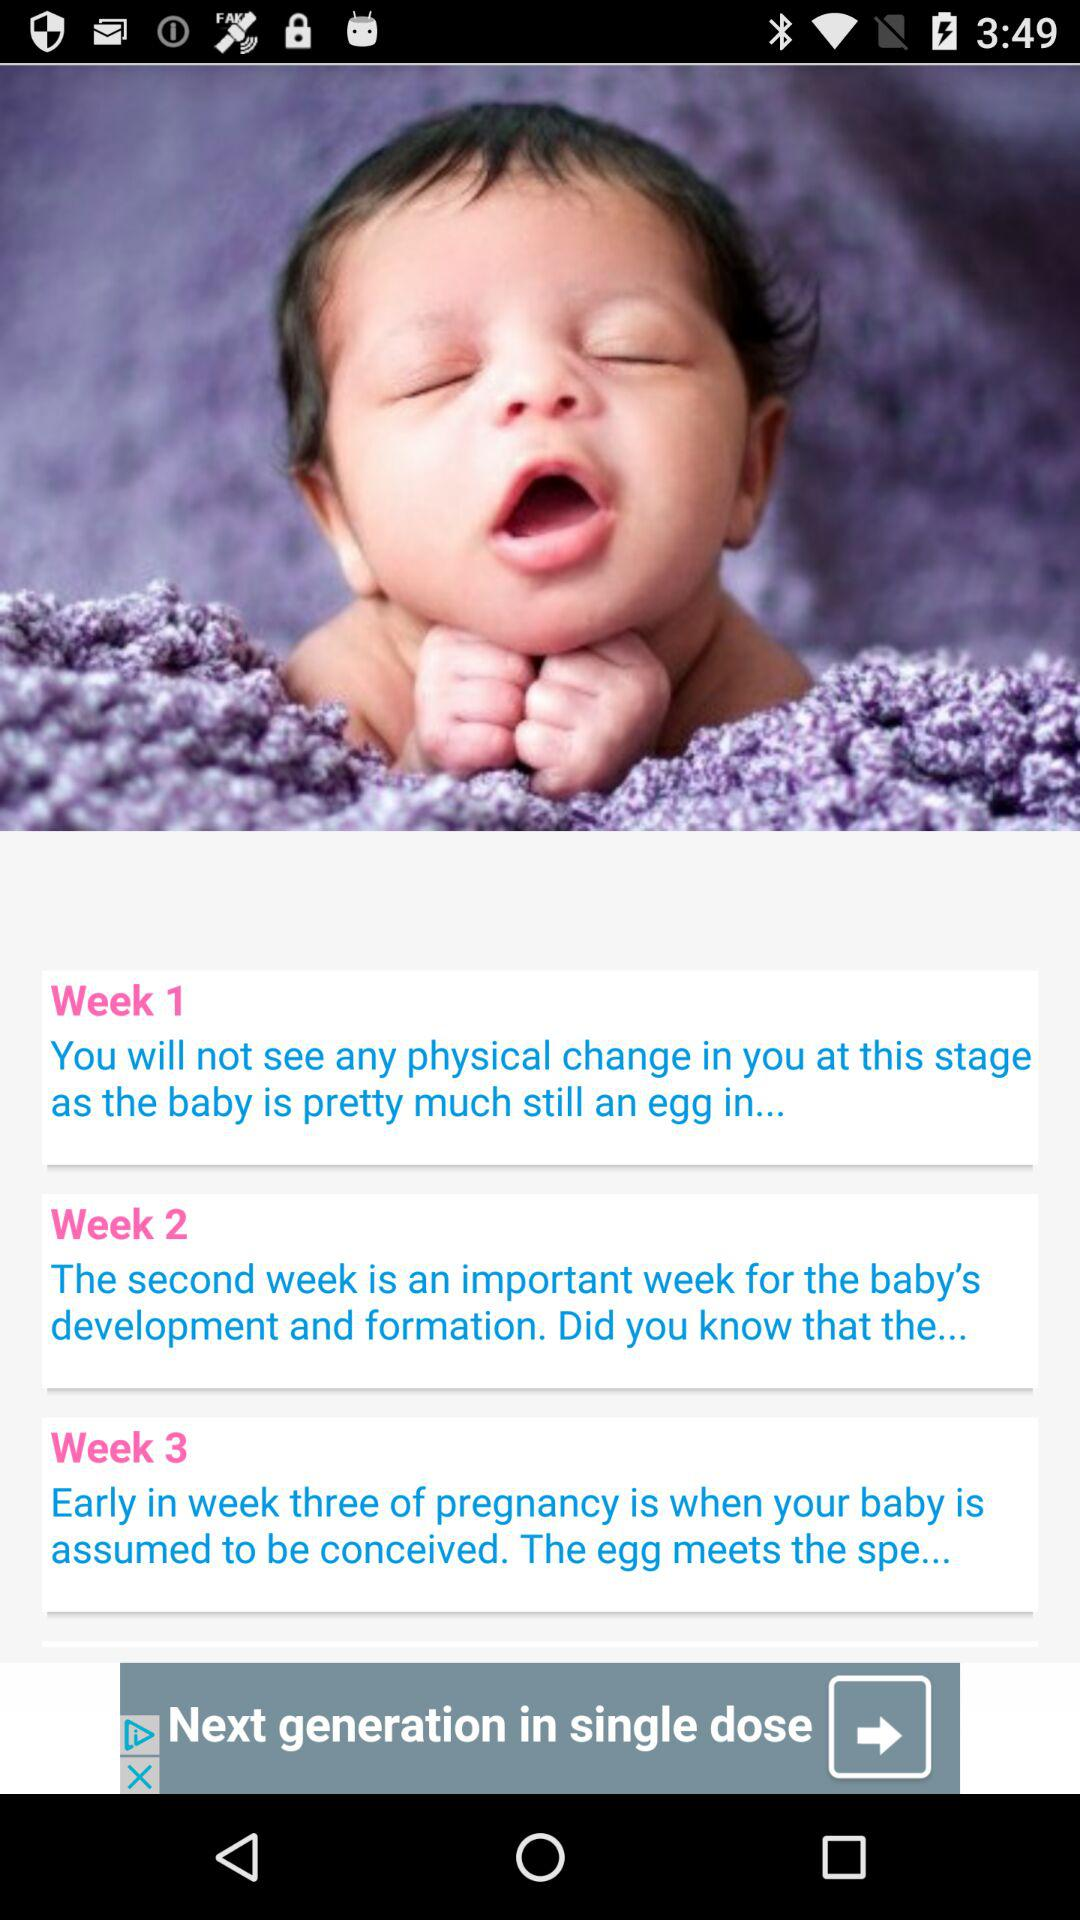How many total weeks does a baby take to be conceived? The baby takes three weeks to be conceived. 